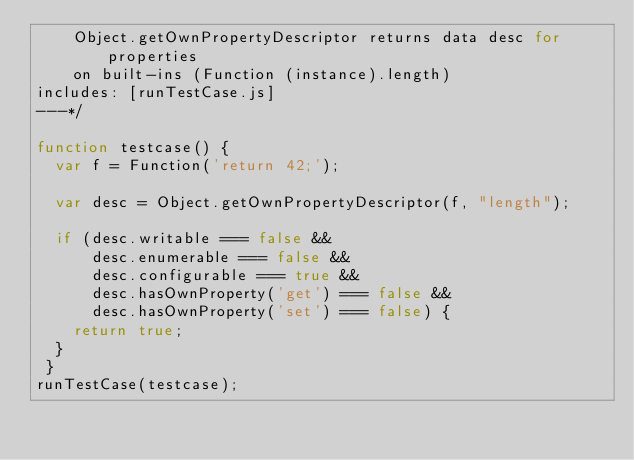<code> <loc_0><loc_0><loc_500><loc_500><_JavaScript_>    Object.getOwnPropertyDescriptor returns data desc for properties
    on built-ins (Function (instance).length)
includes: [runTestCase.js]
---*/

function testcase() {
  var f = Function('return 42;');

  var desc = Object.getOwnPropertyDescriptor(f, "length");

  if (desc.writable === false &&
      desc.enumerable === false &&
      desc.configurable === true &&
      desc.hasOwnProperty('get') === false &&
      desc.hasOwnProperty('set') === false) {
    return true;
  }
 }
runTestCase(testcase);
</code> 